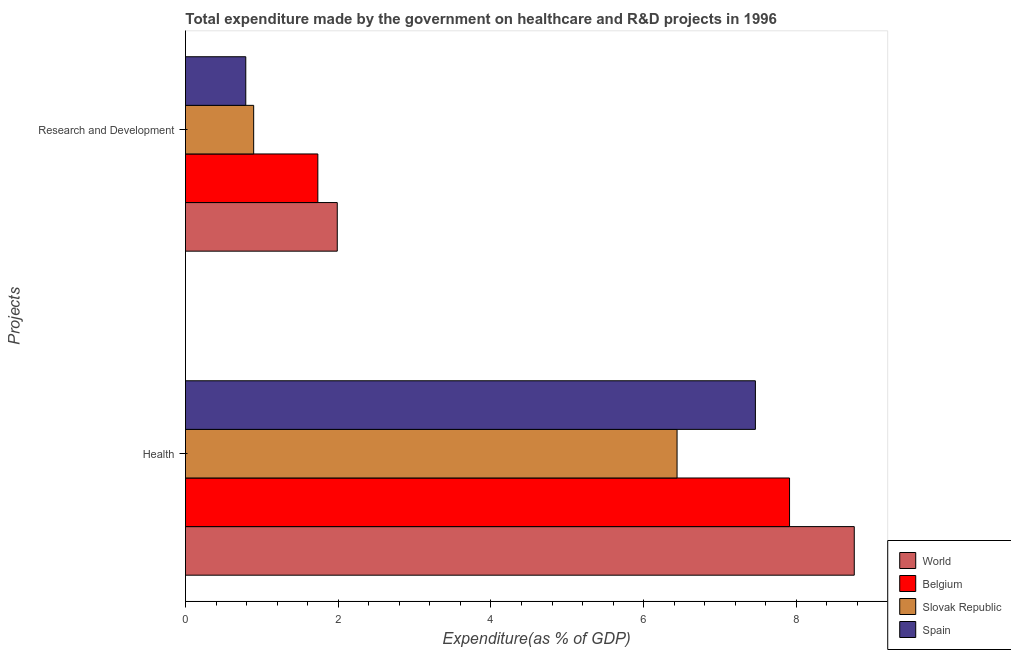How many groups of bars are there?
Your response must be concise. 2. Are the number of bars per tick equal to the number of legend labels?
Offer a terse response. Yes. Are the number of bars on each tick of the Y-axis equal?
Make the answer very short. Yes. How many bars are there on the 2nd tick from the top?
Provide a succinct answer. 4. What is the label of the 2nd group of bars from the top?
Provide a short and direct response. Health. What is the expenditure in healthcare in Belgium?
Offer a very short reply. 7.91. Across all countries, what is the maximum expenditure in r&d?
Offer a terse response. 1.99. Across all countries, what is the minimum expenditure in healthcare?
Offer a terse response. 6.44. In which country was the expenditure in healthcare minimum?
Make the answer very short. Slovak Republic. What is the total expenditure in healthcare in the graph?
Offer a very short reply. 30.57. What is the difference between the expenditure in healthcare in Slovak Republic and that in Spain?
Offer a terse response. -1.03. What is the difference between the expenditure in r&d in Spain and the expenditure in healthcare in Belgium?
Provide a short and direct response. -7.12. What is the average expenditure in healthcare per country?
Provide a succinct answer. 7.64. What is the difference between the expenditure in r&d and expenditure in healthcare in Belgium?
Keep it short and to the point. -6.18. What is the ratio of the expenditure in r&d in Spain to that in World?
Your answer should be compact. 0.4. Is the expenditure in healthcare in Slovak Republic less than that in Spain?
Provide a succinct answer. Yes. What does the 2nd bar from the bottom in Research and Development represents?
Provide a succinct answer. Belgium. Are all the bars in the graph horizontal?
Give a very brief answer. Yes. What is the difference between two consecutive major ticks on the X-axis?
Your answer should be very brief. 2. Are the values on the major ticks of X-axis written in scientific E-notation?
Offer a terse response. No. Does the graph contain any zero values?
Give a very brief answer. No. Does the graph contain grids?
Give a very brief answer. No. How many legend labels are there?
Provide a short and direct response. 4. How are the legend labels stacked?
Ensure brevity in your answer.  Vertical. What is the title of the graph?
Give a very brief answer. Total expenditure made by the government on healthcare and R&D projects in 1996. What is the label or title of the X-axis?
Give a very brief answer. Expenditure(as % of GDP). What is the label or title of the Y-axis?
Offer a very short reply. Projects. What is the Expenditure(as % of GDP) in World in Health?
Make the answer very short. 8.76. What is the Expenditure(as % of GDP) in Belgium in Health?
Ensure brevity in your answer.  7.91. What is the Expenditure(as % of GDP) of Slovak Republic in Health?
Ensure brevity in your answer.  6.44. What is the Expenditure(as % of GDP) in Spain in Health?
Your answer should be very brief. 7.46. What is the Expenditure(as % of GDP) of World in Research and Development?
Your response must be concise. 1.99. What is the Expenditure(as % of GDP) in Belgium in Research and Development?
Ensure brevity in your answer.  1.73. What is the Expenditure(as % of GDP) of Slovak Republic in Research and Development?
Give a very brief answer. 0.89. What is the Expenditure(as % of GDP) in Spain in Research and Development?
Offer a terse response. 0.79. Across all Projects, what is the maximum Expenditure(as % of GDP) of World?
Make the answer very short. 8.76. Across all Projects, what is the maximum Expenditure(as % of GDP) in Belgium?
Your answer should be very brief. 7.91. Across all Projects, what is the maximum Expenditure(as % of GDP) in Slovak Republic?
Offer a terse response. 6.44. Across all Projects, what is the maximum Expenditure(as % of GDP) in Spain?
Give a very brief answer. 7.46. Across all Projects, what is the minimum Expenditure(as % of GDP) of World?
Give a very brief answer. 1.99. Across all Projects, what is the minimum Expenditure(as % of GDP) in Belgium?
Offer a terse response. 1.73. Across all Projects, what is the minimum Expenditure(as % of GDP) of Slovak Republic?
Offer a terse response. 0.89. Across all Projects, what is the minimum Expenditure(as % of GDP) of Spain?
Your answer should be very brief. 0.79. What is the total Expenditure(as % of GDP) of World in the graph?
Offer a terse response. 10.75. What is the total Expenditure(as % of GDP) of Belgium in the graph?
Provide a short and direct response. 9.64. What is the total Expenditure(as % of GDP) in Slovak Republic in the graph?
Ensure brevity in your answer.  7.33. What is the total Expenditure(as % of GDP) of Spain in the graph?
Keep it short and to the point. 8.25. What is the difference between the Expenditure(as % of GDP) of World in Health and that in Research and Development?
Keep it short and to the point. 6.77. What is the difference between the Expenditure(as % of GDP) of Belgium in Health and that in Research and Development?
Provide a succinct answer. 6.18. What is the difference between the Expenditure(as % of GDP) of Slovak Republic in Health and that in Research and Development?
Your response must be concise. 5.54. What is the difference between the Expenditure(as % of GDP) of Spain in Health and that in Research and Development?
Provide a succinct answer. 6.67. What is the difference between the Expenditure(as % of GDP) of World in Health and the Expenditure(as % of GDP) of Belgium in Research and Development?
Provide a short and direct response. 7.02. What is the difference between the Expenditure(as % of GDP) of World in Health and the Expenditure(as % of GDP) of Slovak Republic in Research and Development?
Ensure brevity in your answer.  7.86. What is the difference between the Expenditure(as % of GDP) of World in Health and the Expenditure(as % of GDP) of Spain in Research and Development?
Your answer should be compact. 7.97. What is the difference between the Expenditure(as % of GDP) of Belgium in Health and the Expenditure(as % of GDP) of Slovak Republic in Research and Development?
Make the answer very short. 7.02. What is the difference between the Expenditure(as % of GDP) of Belgium in Health and the Expenditure(as % of GDP) of Spain in Research and Development?
Your answer should be very brief. 7.12. What is the difference between the Expenditure(as % of GDP) in Slovak Republic in Health and the Expenditure(as % of GDP) in Spain in Research and Development?
Provide a short and direct response. 5.65. What is the average Expenditure(as % of GDP) in World per Projects?
Your response must be concise. 5.37. What is the average Expenditure(as % of GDP) in Belgium per Projects?
Your answer should be very brief. 4.82. What is the average Expenditure(as % of GDP) of Slovak Republic per Projects?
Offer a very short reply. 3.67. What is the average Expenditure(as % of GDP) of Spain per Projects?
Offer a very short reply. 4.13. What is the difference between the Expenditure(as % of GDP) in World and Expenditure(as % of GDP) in Belgium in Health?
Your response must be concise. 0.85. What is the difference between the Expenditure(as % of GDP) in World and Expenditure(as % of GDP) in Slovak Republic in Health?
Your answer should be compact. 2.32. What is the difference between the Expenditure(as % of GDP) in World and Expenditure(as % of GDP) in Spain in Health?
Give a very brief answer. 1.29. What is the difference between the Expenditure(as % of GDP) of Belgium and Expenditure(as % of GDP) of Slovak Republic in Health?
Offer a terse response. 1.47. What is the difference between the Expenditure(as % of GDP) of Belgium and Expenditure(as % of GDP) of Spain in Health?
Keep it short and to the point. 0.45. What is the difference between the Expenditure(as % of GDP) in Slovak Republic and Expenditure(as % of GDP) in Spain in Health?
Your answer should be compact. -1.03. What is the difference between the Expenditure(as % of GDP) in World and Expenditure(as % of GDP) in Belgium in Research and Development?
Give a very brief answer. 0.25. What is the difference between the Expenditure(as % of GDP) in World and Expenditure(as % of GDP) in Slovak Republic in Research and Development?
Your answer should be very brief. 1.09. What is the difference between the Expenditure(as % of GDP) in World and Expenditure(as % of GDP) in Spain in Research and Development?
Make the answer very short. 1.2. What is the difference between the Expenditure(as % of GDP) of Belgium and Expenditure(as % of GDP) of Slovak Republic in Research and Development?
Make the answer very short. 0.84. What is the difference between the Expenditure(as % of GDP) of Belgium and Expenditure(as % of GDP) of Spain in Research and Development?
Your response must be concise. 0.94. What is the difference between the Expenditure(as % of GDP) in Slovak Republic and Expenditure(as % of GDP) in Spain in Research and Development?
Your response must be concise. 0.1. What is the ratio of the Expenditure(as % of GDP) in World in Health to that in Research and Development?
Your response must be concise. 4.41. What is the ratio of the Expenditure(as % of GDP) in Belgium in Health to that in Research and Development?
Offer a terse response. 4.56. What is the ratio of the Expenditure(as % of GDP) of Slovak Republic in Health to that in Research and Development?
Provide a short and direct response. 7.21. What is the ratio of the Expenditure(as % of GDP) of Spain in Health to that in Research and Development?
Your answer should be very brief. 9.45. What is the difference between the highest and the second highest Expenditure(as % of GDP) of World?
Make the answer very short. 6.77. What is the difference between the highest and the second highest Expenditure(as % of GDP) of Belgium?
Provide a short and direct response. 6.18. What is the difference between the highest and the second highest Expenditure(as % of GDP) of Slovak Republic?
Your answer should be very brief. 5.54. What is the difference between the highest and the second highest Expenditure(as % of GDP) of Spain?
Offer a terse response. 6.67. What is the difference between the highest and the lowest Expenditure(as % of GDP) in World?
Give a very brief answer. 6.77. What is the difference between the highest and the lowest Expenditure(as % of GDP) in Belgium?
Provide a succinct answer. 6.18. What is the difference between the highest and the lowest Expenditure(as % of GDP) in Slovak Republic?
Your response must be concise. 5.54. What is the difference between the highest and the lowest Expenditure(as % of GDP) of Spain?
Make the answer very short. 6.67. 